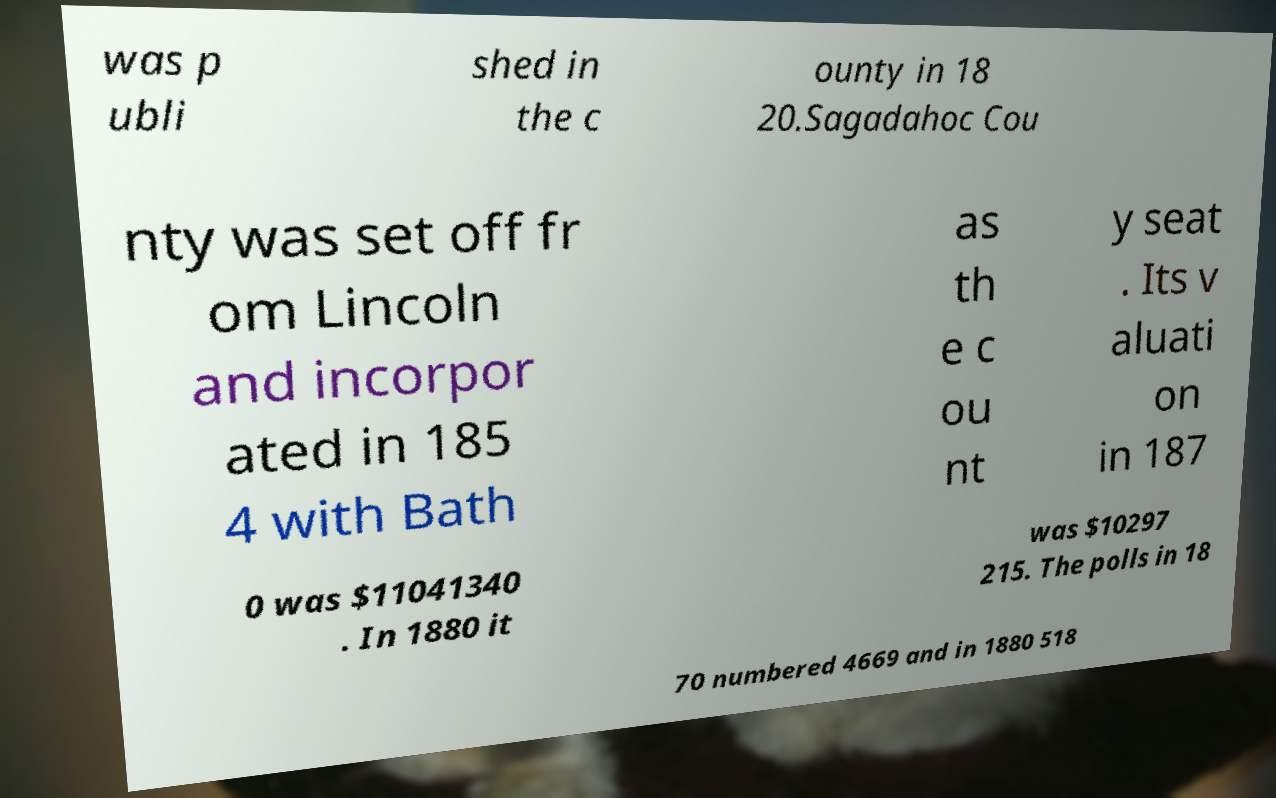Could you assist in decoding the text presented in this image and type it out clearly? was p ubli shed in the c ounty in 18 20.Sagadahoc Cou nty was set off fr om Lincoln and incorpor ated in 185 4 with Bath as th e c ou nt y seat . Its v aluati on in 187 0 was $11041340 . In 1880 it was $10297 215. The polls in 18 70 numbered 4669 and in 1880 518 